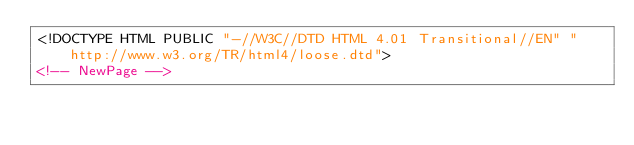Convert code to text. <code><loc_0><loc_0><loc_500><loc_500><_HTML_><!DOCTYPE HTML PUBLIC "-//W3C//DTD HTML 4.01 Transitional//EN" "http://www.w3.org/TR/html4/loose.dtd">
<!-- NewPage --></code> 